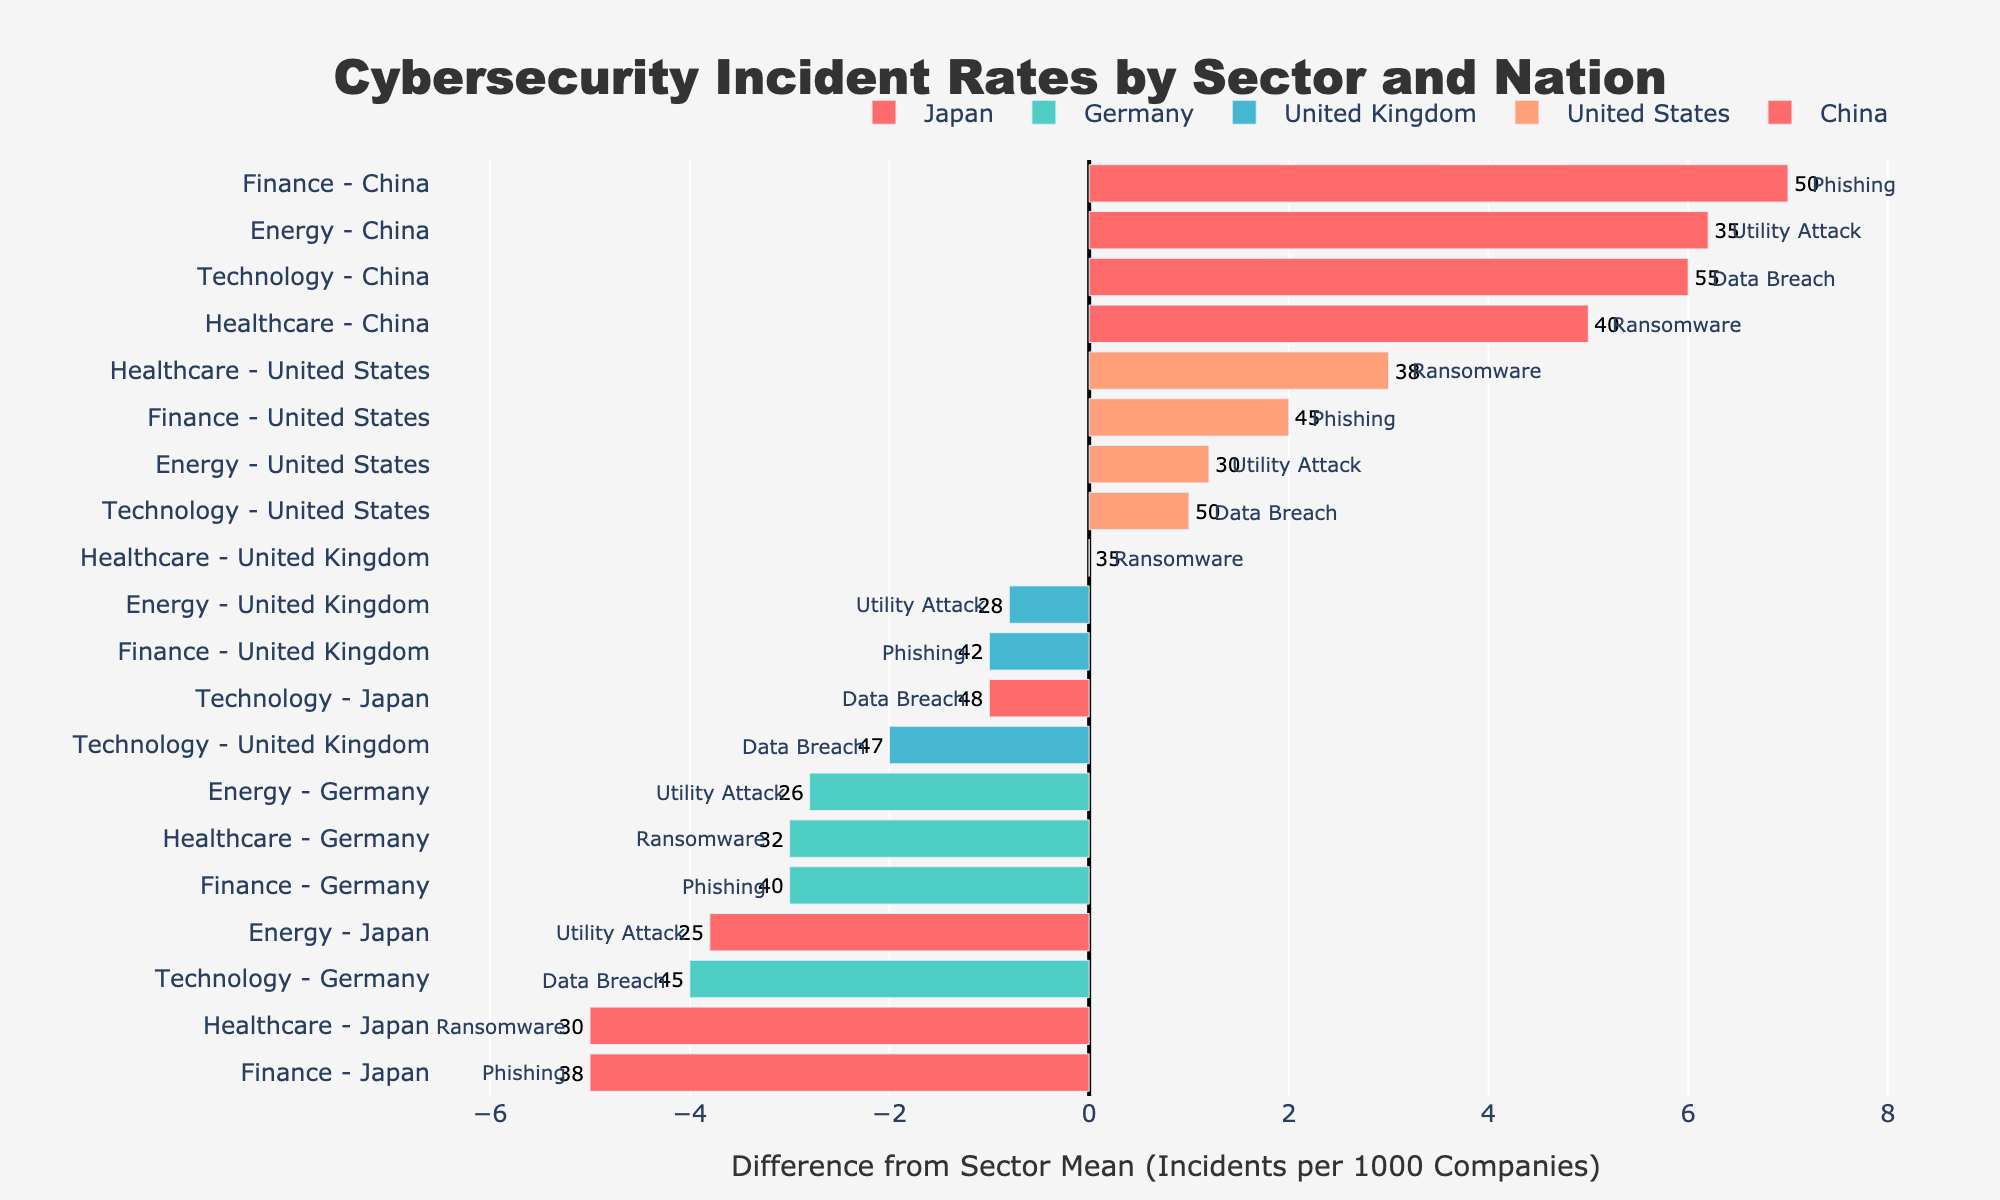Which sector in China has the highest incident rate? By looking at the lengths of the bars for China, the Technology sector has the largest bar indicating the highest incident rate among sectors.
Answer: Technology How does the incident rate for the Finance sector in the United Kingdom compare to the mean incident rate for the same sector? The mean incident rate for the Finance sector can be calculated from the data across all nations. The bar for the United Kingdom's Finance sector is labeled such that its value can be visually compared against the mean line in the chart.
Answer: 42 vs mean of 43 Which country has the smallest deviation from the mean in the Healthcare sector? The smallest deviation from the mean can be identified by the shortest bar (in absolute terms) in the Healthcare sector.
Answer: Japan Is the incident rate for the Energy sector in the United States above or below the mean for this sector? By examining the bar for the Energy sector in the United States and comparing its extension to the mean line, it can be observed whether it is above or below the mean.
Answer: Above What is the most common type of cybersecurity incident in the Technology sector? Each bar in the Technology sector is annotated with the type of incident, so the most recurring annotation can be identified.
Answer: Data Breach In which country does the Finance sector have a higher incident rate compared to its national average? By comparing the incident rate of the Finance sector bar to the country mean line for each nation, the country with a higher Finance sector rate can be identified.
Answer: China How does the Healthcare sector’s incident rate in Germany compare to that of Japan? By looking at the bars for the Healthcare sector in Germany and Japan, it can be seen which one has a longer length.
Answer: Germany has a higher rate Which sector and nation pair stands out for having the closest incident rate to their sectoral mean? The pair with the shortest absolute bar length (difference from the mean) across all sectors and nations stands out.
Answer: Japan's Healthcare sector Which sector appears to face the highest variability in incident rates across the nations? The sector with the widest range of differences from the mean line (i.e., having the longest and shortest bars) indicates the highest variability.
Answer: Technology Which nation’s Energy sector shows the highest increase from the mean? By identifying the nation within the Energy sector that has the longest bar extending above the mean line.
Answer: China 